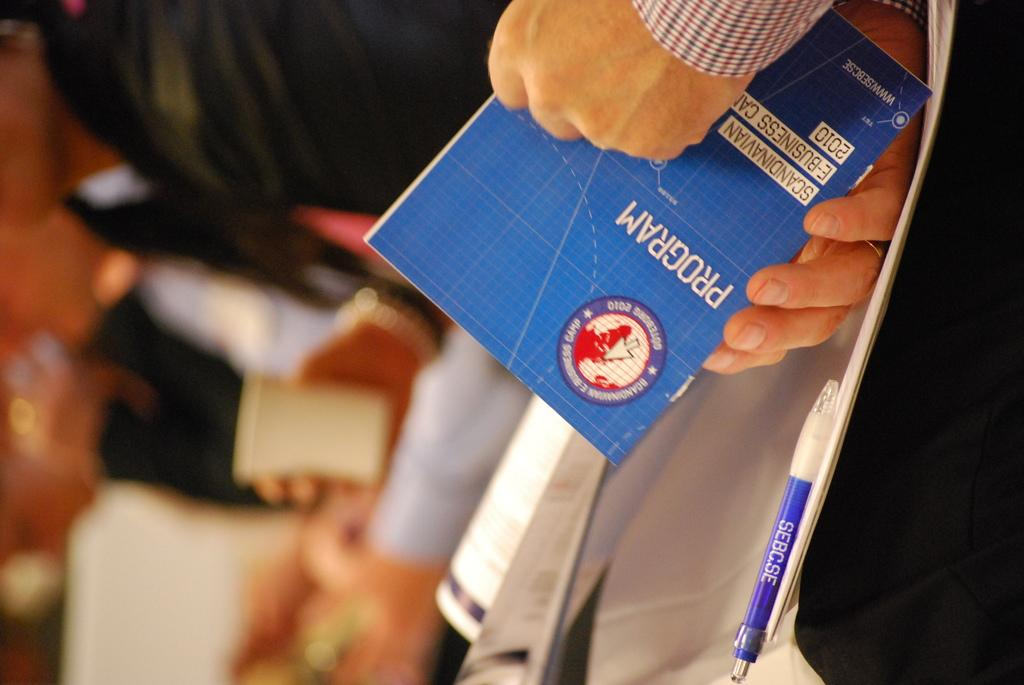What is the person in the image doing? The person in the image is holding a book. What else can be seen in the image besides the person? There are books, bags, and a pen in the image. Can you describe the other objects present in the image? There are other objects present in the image, but their specific details are not mentioned in the provided facts. How many bikes are parked at the airport in the image? There is no mention of bikes or an airport in the image; the image features a person holding a book and other objects. 